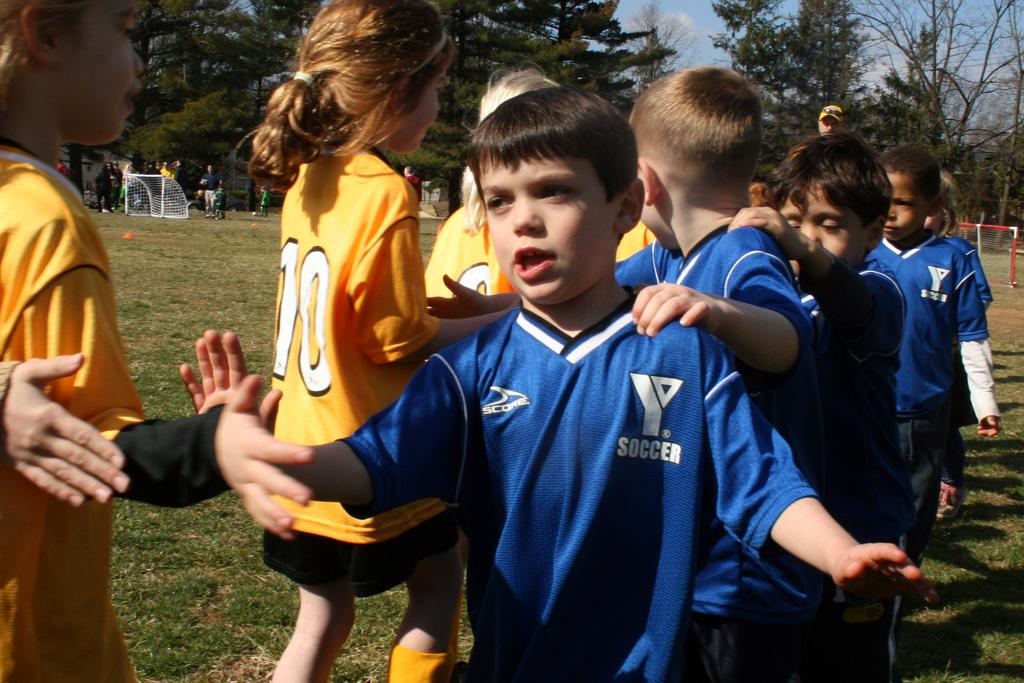<image>
Write a terse but informative summary of the picture. Boy wearing a jersey that says Soccer on it. 